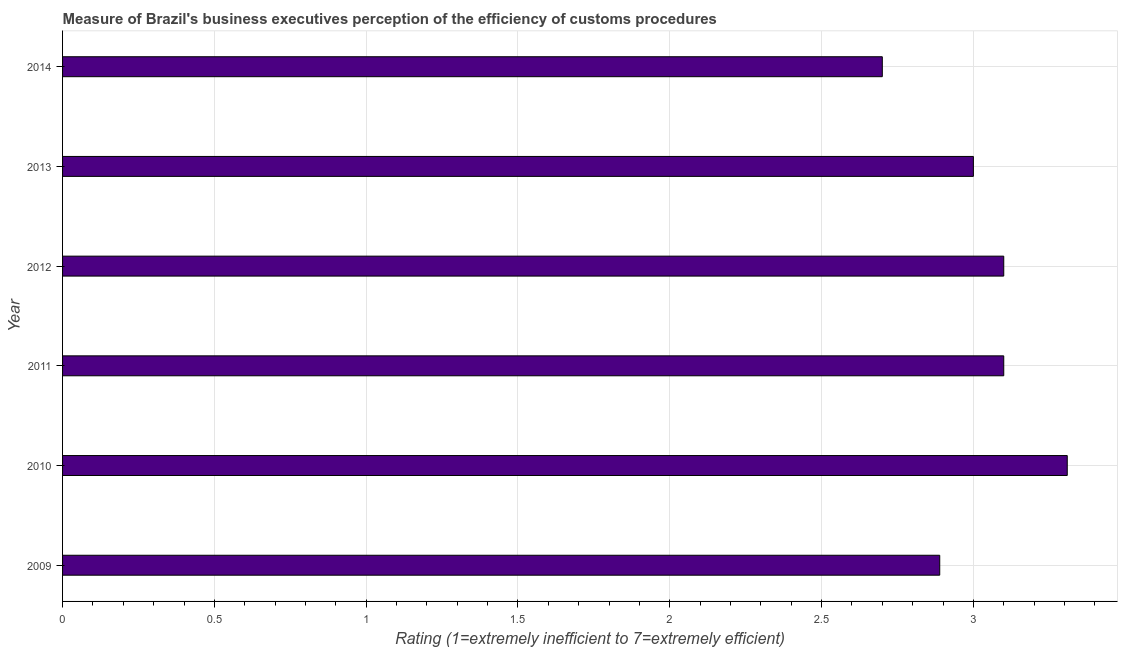What is the title of the graph?
Give a very brief answer. Measure of Brazil's business executives perception of the efficiency of customs procedures. What is the label or title of the X-axis?
Provide a succinct answer. Rating (1=extremely inefficient to 7=extremely efficient). What is the label or title of the Y-axis?
Offer a very short reply. Year. What is the rating measuring burden of customs procedure in 2010?
Offer a terse response. 3.31. Across all years, what is the maximum rating measuring burden of customs procedure?
Offer a terse response. 3.31. In which year was the rating measuring burden of customs procedure minimum?
Offer a very short reply. 2014. What is the sum of the rating measuring burden of customs procedure?
Your answer should be very brief. 18.1. What is the difference between the rating measuring burden of customs procedure in 2012 and 2014?
Provide a succinct answer. 0.4. What is the average rating measuring burden of customs procedure per year?
Ensure brevity in your answer.  3.02. What is the median rating measuring burden of customs procedure?
Your answer should be very brief. 3.05. Do a majority of the years between 2009 and 2013 (inclusive) have rating measuring burden of customs procedure greater than 2.8 ?
Provide a short and direct response. Yes. What is the ratio of the rating measuring burden of customs procedure in 2010 to that in 2012?
Provide a short and direct response. 1.07. What is the difference between the highest and the second highest rating measuring burden of customs procedure?
Your answer should be very brief. 0.21. What is the difference between the highest and the lowest rating measuring burden of customs procedure?
Provide a succinct answer. 0.61. How many bars are there?
Ensure brevity in your answer.  6. Are all the bars in the graph horizontal?
Keep it short and to the point. Yes. How many years are there in the graph?
Provide a short and direct response. 6. What is the difference between two consecutive major ticks on the X-axis?
Ensure brevity in your answer.  0.5. Are the values on the major ticks of X-axis written in scientific E-notation?
Your response must be concise. No. What is the Rating (1=extremely inefficient to 7=extremely efficient) of 2009?
Offer a terse response. 2.89. What is the Rating (1=extremely inefficient to 7=extremely efficient) in 2010?
Make the answer very short. 3.31. What is the Rating (1=extremely inefficient to 7=extremely efficient) of 2011?
Give a very brief answer. 3.1. What is the Rating (1=extremely inefficient to 7=extremely efficient) of 2013?
Give a very brief answer. 3. What is the Rating (1=extremely inefficient to 7=extremely efficient) in 2014?
Provide a short and direct response. 2.7. What is the difference between the Rating (1=extremely inefficient to 7=extremely efficient) in 2009 and 2010?
Provide a short and direct response. -0.42. What is the difference between the Rating (1=extremely inefficient to 7=extremely efficient) in 2009 and 2011?
Ensure brevity in your answer.  -0.21. What is the difference between the Rating (1=extremely inefficient to 7=extremely efficient) in 2009 and 2012?
Keep it short and to the point. -0.21. What is the difference between the Rating (1=extremely inefficient to 7=extremely efficient) in 2009 and 2013?
Provide a short and direct response. -0.11. What is the difference between the Rating (1=extremely inefficient to 7=extremely efficient) in 2009 and 2014?
Offer a very short reply. 0.19. What is the difference between the Rating (1=extremely inefficient to 7=extremely efficient) in 2010 and 2011?
Your answer should be very brief. 0.21. What is the difference between the Rating (1=extremely inefficient to 7=extremely efficient) in 2010 and 2012?
Give a very brief answer. 0.21. What is the difference between the Rating (1=extremely inefficient to 7=extremely efficient) in 2010 and 2013?
Your answer should be very brief. 0.31. What is the difference between the Rating (1=extremely inefficient to 7=extremely efficient) in 2010 and 2014?
Ensure brevity in your answer.  0.61. What is the difference between the Rating (1=extremely inefficient to 7=extremely efficient) in 2011 and 2013?
Your answer should be very brief. 0.1. What is the difference between the Rating (1=extremely inefficient to 7=extremely efficient) in 2011 and 2014?
Offer a terse response. 0.4. What is the difference between the Rating (1=extremely inefficient to 7=extremely efficient) in 2013 and 2014?
Provide a succinct answer. 0.3. What is the ratio of the Rating (1=extremely inefficient to 7=extremely efficient) in 2009 to that in 2010?
Offer a very short reply. 0.87. What is the ratio of the Rating (1=extremely inefficient to 7=extremely efficient) in 2009 to that in 2011?
Make the answer very short. 0.93. What is the ratio of the Rating (1=extremely inefficient to 7=extremely efficient) in 2009 to that in 2012?
Ensure brevity in your answer.  0.93. What is the ratio of the Rating (1=extremely inefficient to 7=extremely efficient) in 2009 to that in 2013?
Offer a very short reply. 0.96. What is the ratio of the Rating (1=extremely inefficient to 7=extremely efficient) in 2009 to that in 2014?
Ensure brevity in your answer.  1.07. What is the ratio of the Rating (1=extremely inefficient to 7=extremely efficient) in 2010 to that in 2011?
Ensure brevity in your answer.  1.07. What is the ratio of the Rating (1=extremely inefficient to 7=extremely efficient) in 2010 to that in 2012?
Keep it short and to the point. 1.07. What is the ratio of the Rating (1=extremely inefficient to 7=extremely efficient) in 2010 to that in 2013?
Provide a short and direct response. 1.1. What is the ratio of the Rating (1=extremely inefficient to 7=extremely efficient) in 2010 to that in 2014?
Your response must be concise. 1.23. What is the ratio of the Rating (1=extremely inefficient to 7=extremely efficient) in 2011 to that in 2012?
Your response must be concise. 1. What is the ratio of the Rating (1=extremely inefficient to 7=extremely efficient) in 2011 to that in 2013?
Offer a terse response. 1.03. What is the ratio of the Rating (1=extremely inefficient to 7=extremely efficient) in 2011 to that in 2014?
Give a very brief answer. 1.15. What is the ratio of the Rating (1=extremely inefficient to 7=extremely efficient) in 2012 to that in 2013?
Your answer should be compact. 1.03. What is the ratio of the Rating (1=extremely inefficient to 7=extremely efficient) in 2012 to that in 2014?
Make the answer very short. 1.15. What is the ratio of the Rating (1=extremely inefficient to 7=extremely efficient) in 2013 to that in 2014?
Your response must be concise. 1.11. 